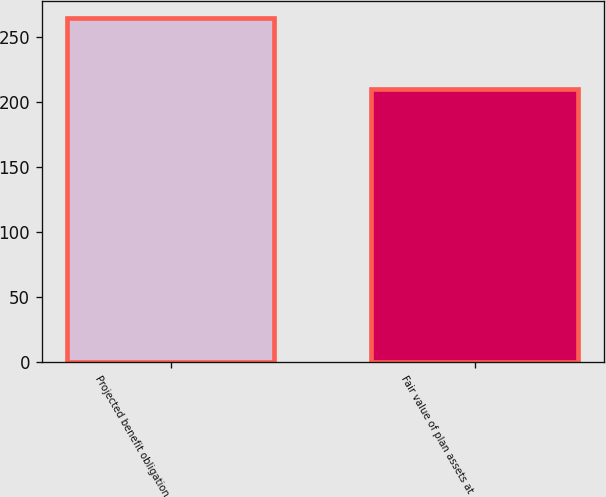<chart> <loc_0><loc_0><loc_500><loc_500><bar_chart><fcel>Projected benefit obligation<fcel>Fair value of plan assets at<nl><fcel>264<fcel>210<nl></chart> 